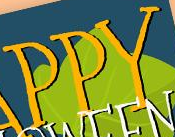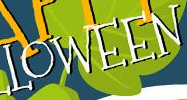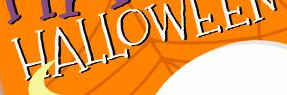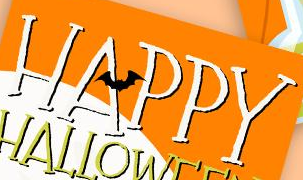Read the text from these images in sequence, separated by a semicolon. PPY; LOWEEN; HALLOWEEN; HAPPY 